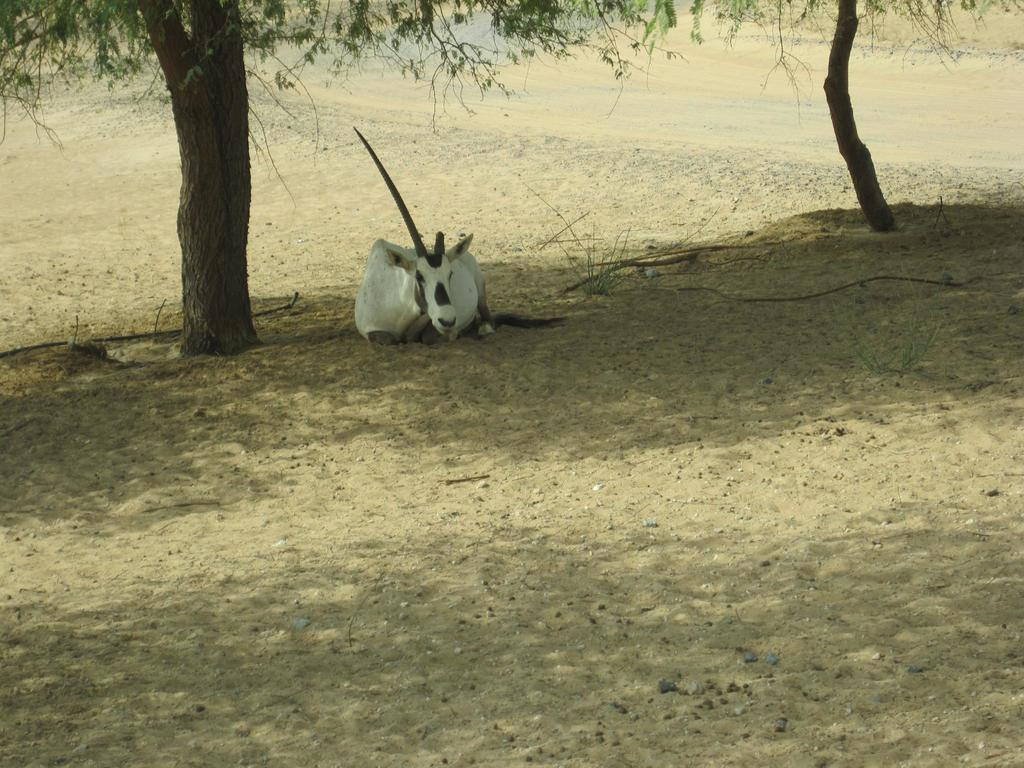What type of animal is in the image? There is an animal in the image, but its specific type is not mentioned in the facts. What color is the animal in the image? The animal is black and white in color. What type of terrain is visible in the image? There is sand visible in the image. What part of a tree can be seen in the image? There is a tree trunk in the image. What type of plant material is present in the image? There are leaves in the image. What is the price of the board in the image? There is no board present in the image, so it is not possible to determine its price. What type of liquid is being poured in the image? There is no liquid being poured in the image. 